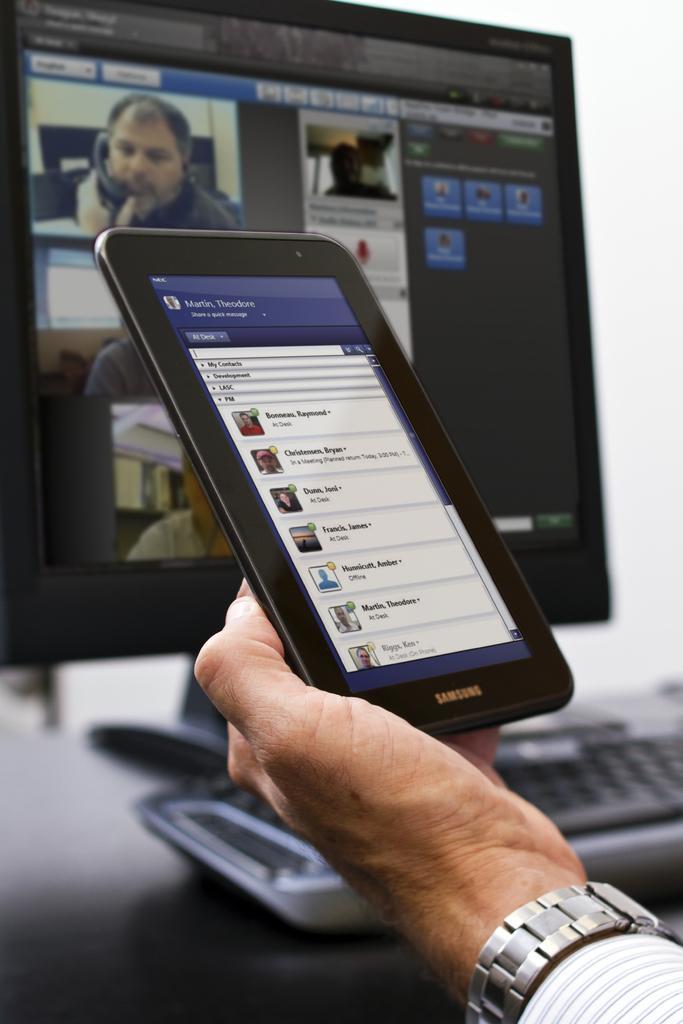Can you describe this image briefly? At the bottom of the image, we can see human hand is holding an ipad with screen. On the screen we can see few image, text and icons. Background we can see the blur view. Here there is a keyboard and monitor. On the monitor screen, we can see few images and some icons. 